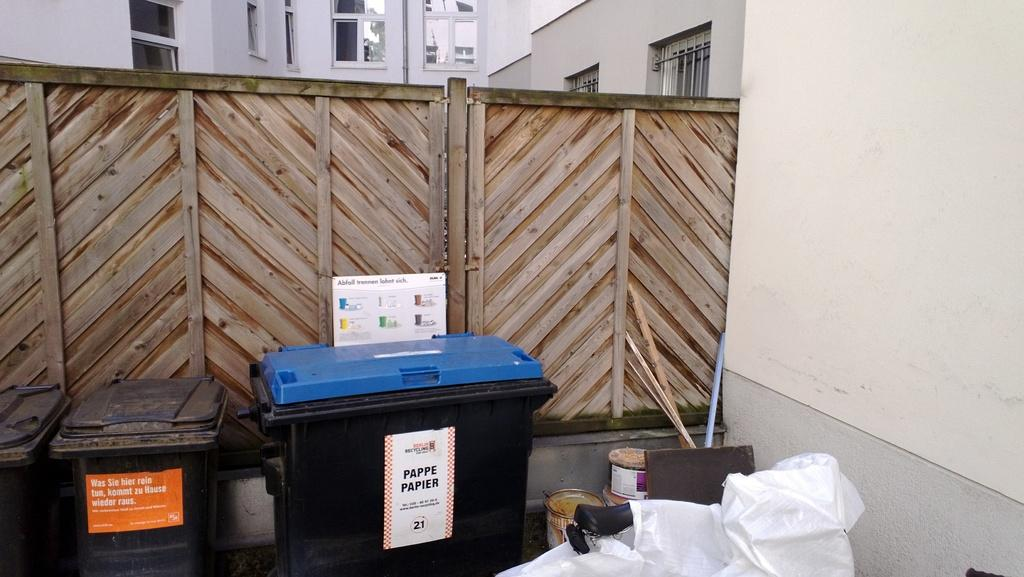Provide a one-sentence caption for the provided image. Two trash cans beside a house and one of them has the Pappe Papier sign at the front. 